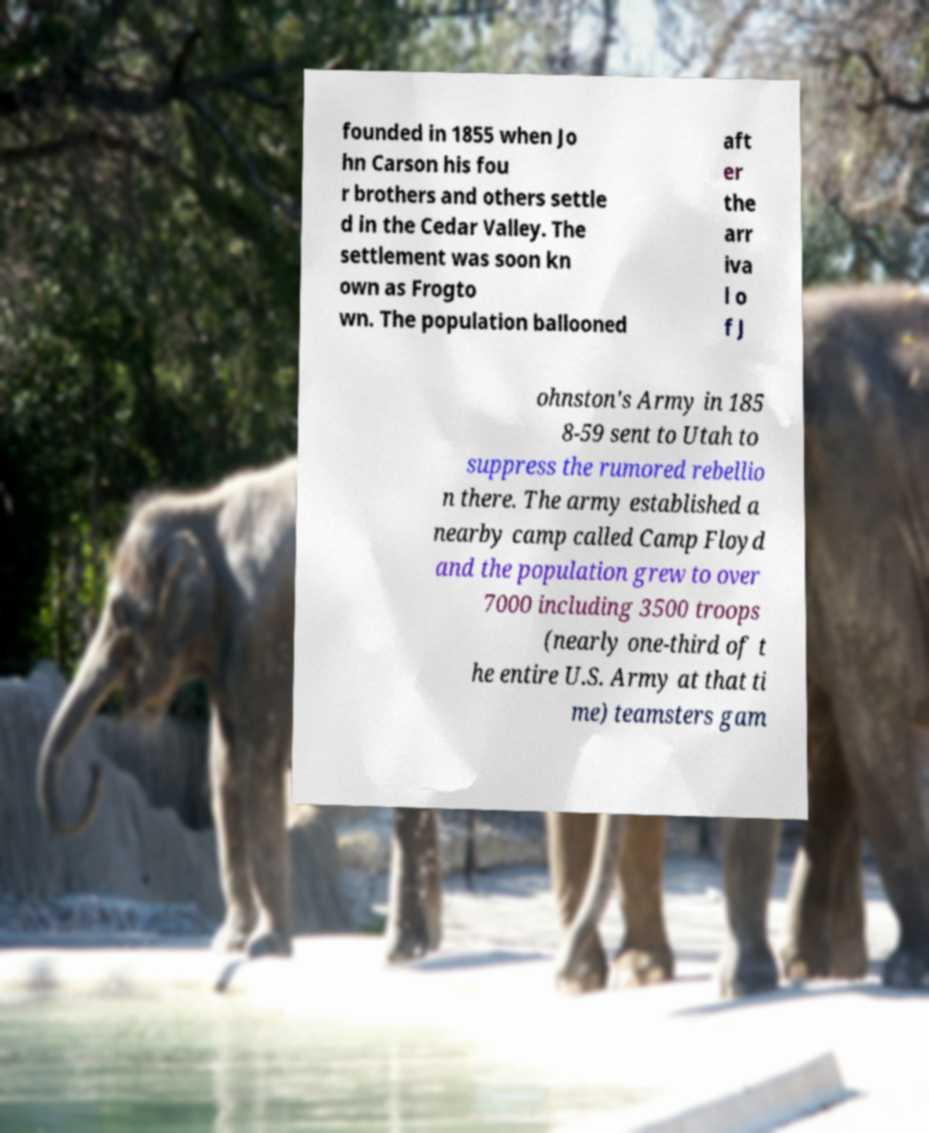There's text embedded in this image that I need extracted. Can you transcribe it verbatim? founded in 1855 when Jo hn Carson his fou r brothers and others settle d in the Cedar Valley. The settlement was soon kn own as Frogto wn. The population ballooned aft er the arr iva l o f J ohnston's Army in 185 8-59 sent to Utah to suppress the rumored rebellio n there. The army established a nearby camp called Camp Floyd and the population grew to over 7000 including 3500 troops (nearly one-third of t he entire U.S. Army at that ti me) teamsters gam 